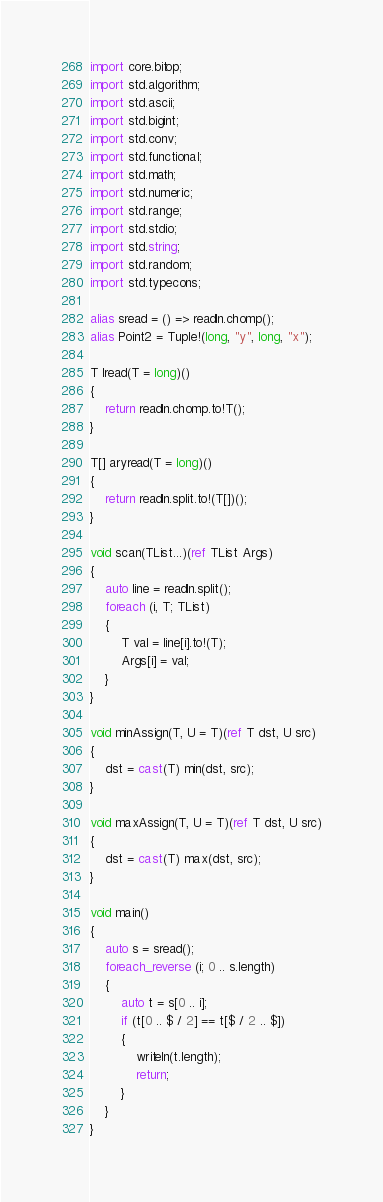Convert code to text. <code><loc_0><loc_0><loc_500><loc_500><_D_>import core.bitop;
import std.algorithm;
import std.ascii;
import std.bigint;
import std.conv;
import std.functional;
import std.math;
import std.numeric;
import std.range;
import std.stdio;
import std.string;
import std.random;
import std.typecons;

alias sread = () => readln.chomp();
alias Point2 = Tuple!(long, "y", long, "x");

T lread(T = long)()
{
    return readln.chomp.to!T();
}

T[] aryread(T = long)()
{
    return readln.split.to!(T[])();
}

void scan(TList...)(ref TList Args)
{
    auto line = readln.split();
    foreach (i, T; TList)
    {
        T val = line[i].to!(T);
        Args[i] = val;
    }
}

void minAssign(T, U = T)(ref T dst, U src)
{
    dst = cast(T) min(dst, src);
}

void maxAssign(T, U = T)(ref T dst, U src)
{
    dst = cast(T) max(dst, src);
}

void main()
{
    auto s = sread();
    foreach_reverse (i; 0 .. s.length)
    {
        auto t = s[0 .. i];
        if (t[0 .. $ / 2] == t[$ / 2 .. $])
        {
            writeln(t.length);
            return;
        }
    }
}
</code> 